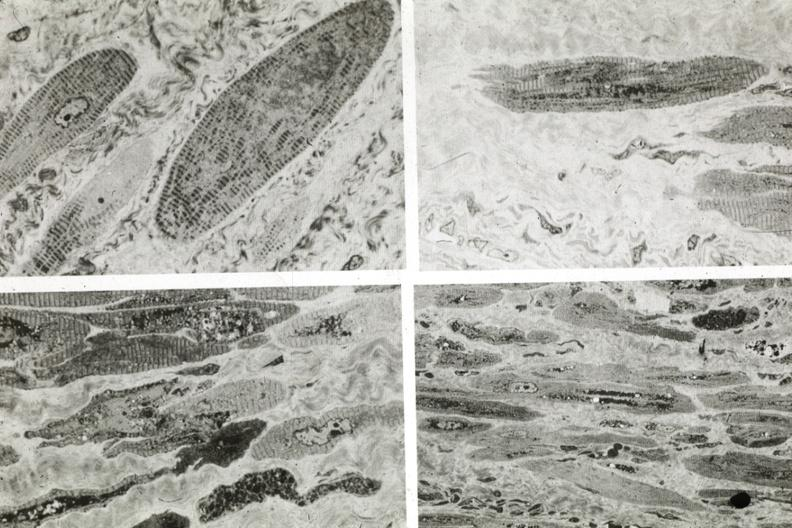does this image show marked fiber atrophy?
Answer the question using a single word or phrase. Yes 